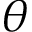<formula> <loc_0><loc_0><loc_500><loc_500>\theta</formula> 